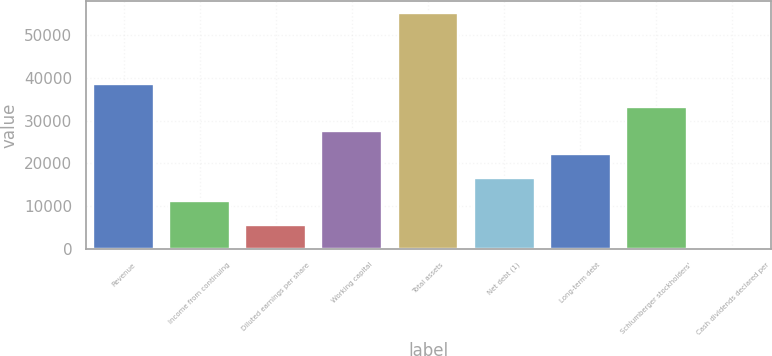<chart> <loc_0><loc_0><loc_500><loc_500><bar_chart><fcel>Revenue<fcel>Income from continuing<fcel>Diluted earnings per share<fcel>Working capital<fcel>Total assets<fcel>Net debt (1)<fcel>Long-term debt<fcel>Schlumberger stockholders'<fcel>Cash dividends declared per<nl><fcel>38641<fcel>11041<fcel>5521<fcel>27601<fcel>55201<fcel>16561<fcel>22081<fcel>33121<fcel>1<nl></chart> 